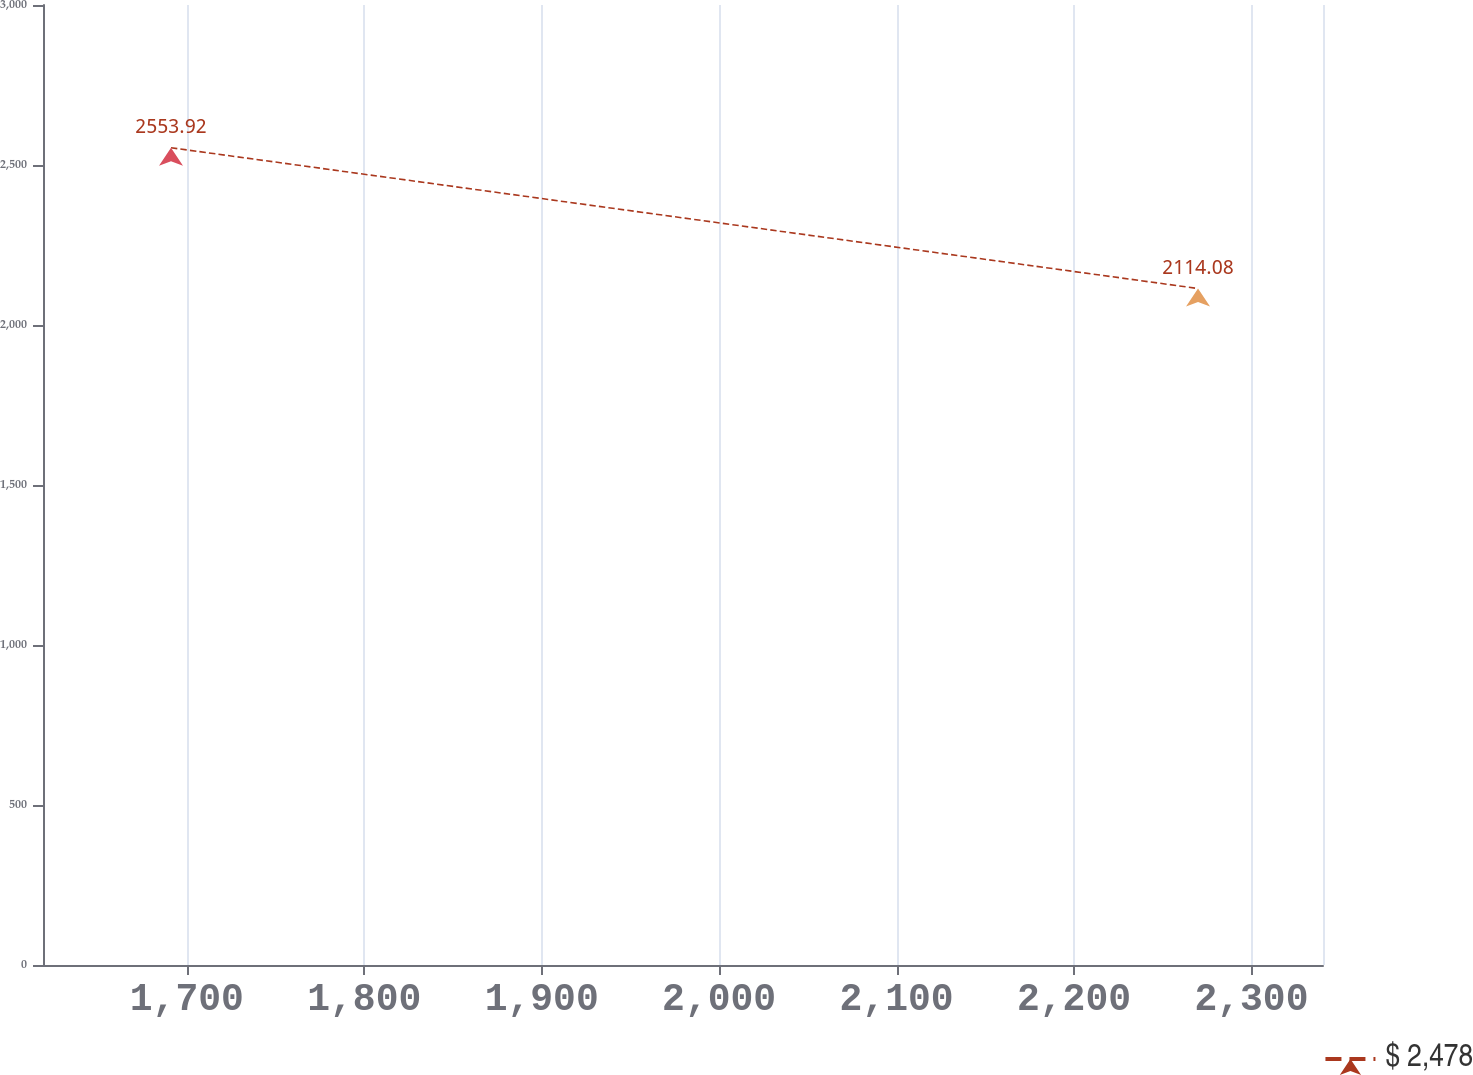<chart> <loc_0><loc_0><loc_500><loc_500><line_chart><ecel><fcel>$ 2,478<nl><fcel>1691.08<fcel>2553.92<nl><fcel>2269.89<fcel>2114.08<nl><fcel>2341.18<fcel>1388.12<nl><fcel>2412.47<fcel>1258.59<nl></chart> 